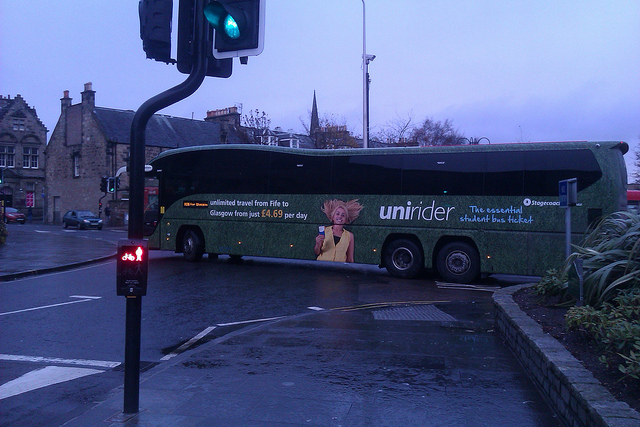What color is the traffic light for pedestrians? The pedestrian traffic light is illuminated with a red figure, indicating that pedestrians should refrain from crossing. 